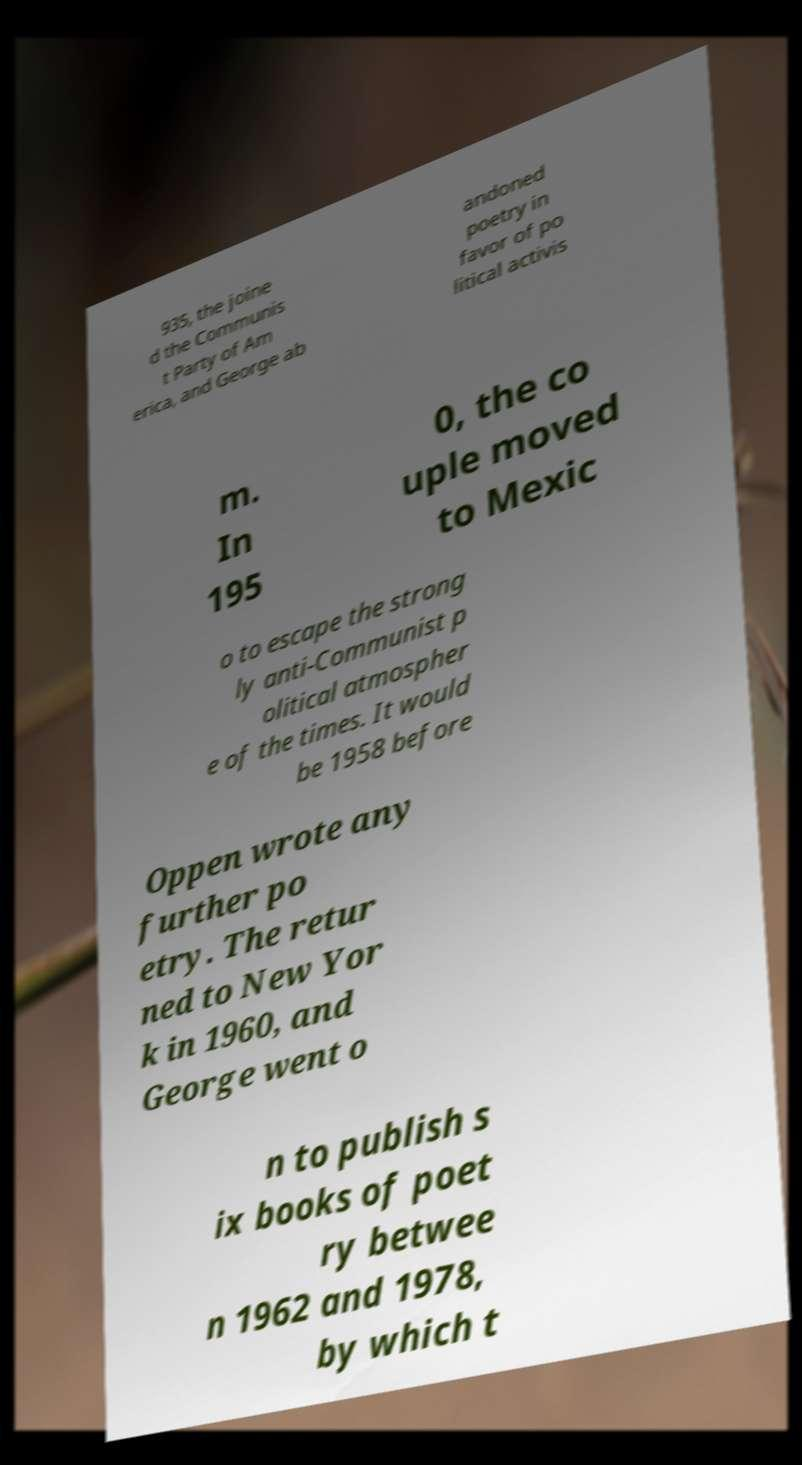There's text embedded in this image that I need extracted. Can you transcribe it verbatim? 935, the joine d the Communis t Party of Am erica, and George ab andoned poetry in favor of po litical activis m. In 195 0, the co uple moved to Mexic o to escape the strong ly anti-Communist p olitical atmospher e of the times. It would be 1958 before Oppen wrote any further po etry. The retur ned to New Yor k in 1960, and George went o n to publish s ix books of poet ry betwee n 1962 and 1978, by which t 